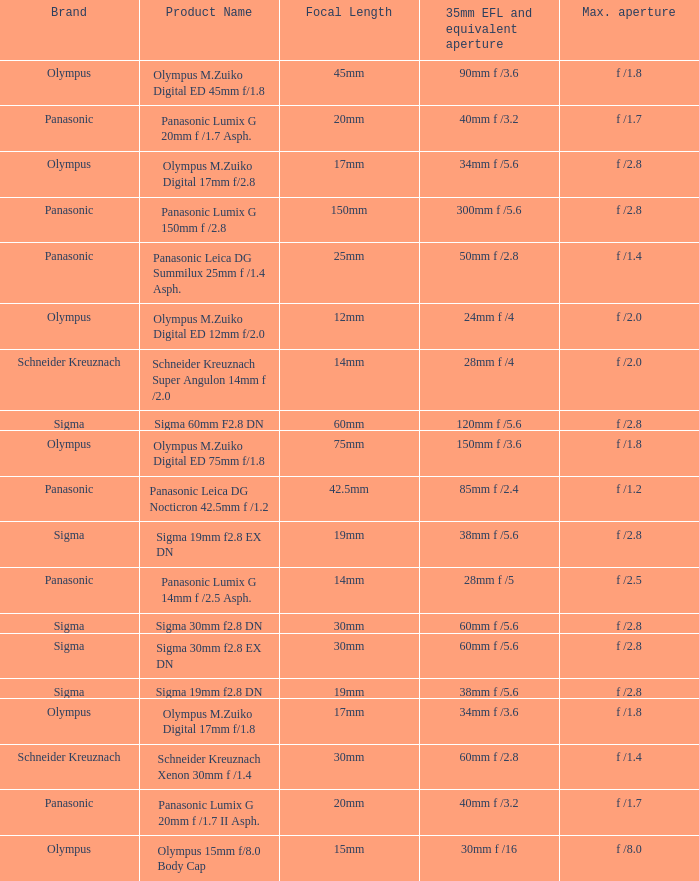What is the 35mm EFL and the equivalent aperture of the lens(es) with a maximum aperture of f /2.5? 28mm f /5. 